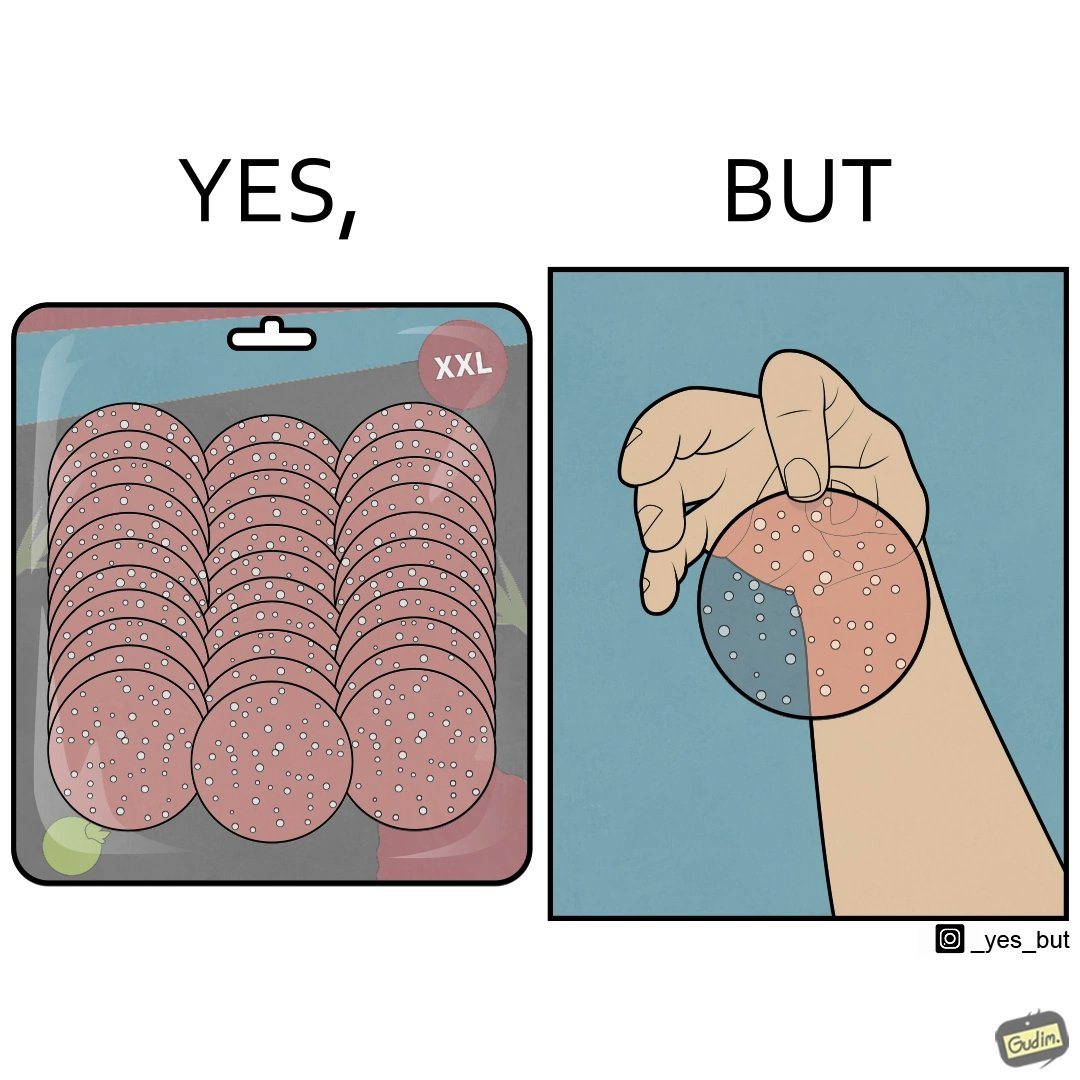Is this image satirical or non-satirical? Yes, this image is satirical. 